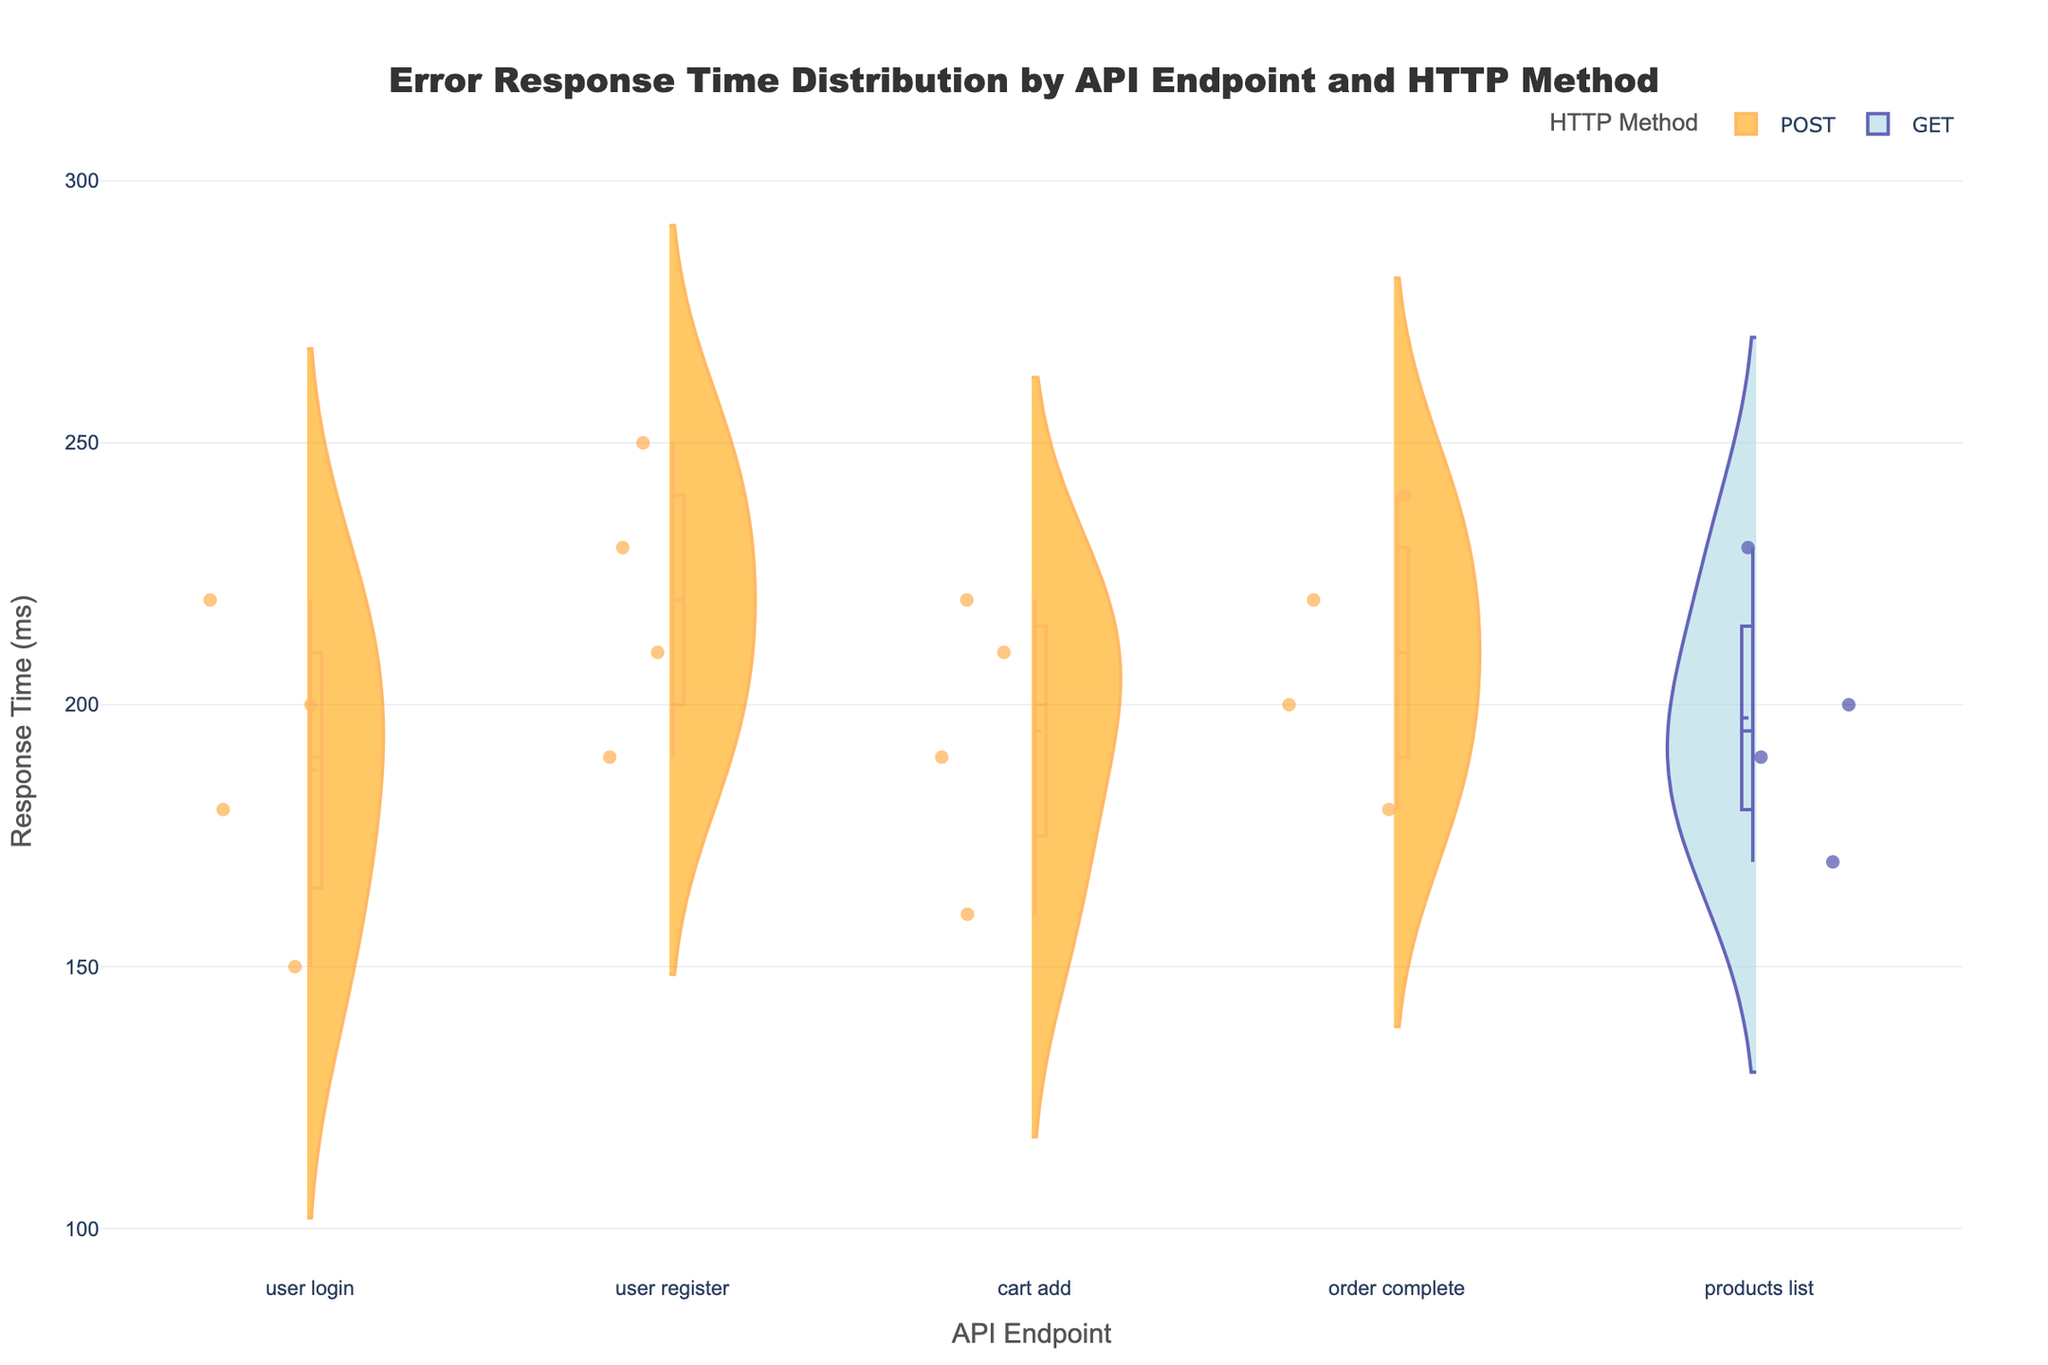What's the title of the chart? The title is prominently displayed at the top of the figure and is generally the first thing you notice.
Answer: Error Response Time Distribution by API Endpoint and HTTP Method What is on the x-axis? The x-axis usually labels the categories or groups being compared. In this case, it shows different API Endpoints represented with line breaks for clarity.
Answer: API Endpoint What is on the y-axis? The y-axis usually represents the variable being measured. In this chart, it is labeled as "Response Time (ms)" which measures the response times of various API endpoints.
Answer: Response Time (ms) Which HTTP method has overall higher response time variability? To determine variability, one needs to look at the spread of the violin plots. POST method has wider violin plots indicating higher variability in response times compared to the GET method.
Answer: POST How does the distribution of response times for `/user/login` endpoint compare between POST and GET methods? The POST method has a wider spread in response times as compared to GET. This is indicated by the larger, more extended violin plot for POST.
Answer: POST shows higher variability What is the average response time for POST requests on the `/order/complete` endpoint? The average response time can be estimated by looking at the mean line visible in the POST violin plot for `/order/complete`.
Answer: Around 210 ms For the `/products/list` endpoint, which HTTP Method has a lower median response time? The median can be inferred from the horizontal line in the middle of the violin plot. Here, the GET method has a slightly lower median response time compared to POST.
Answer: GET How many unique API endpoints are presented in the chart? By counting the different categories on the x-axis, we can determine the number of unique API endpoints shown. There are 5 unique API endpoints.
Answer: 5 Is there an API endpoint where GET requests have higher response times than POST? By visually comparing the top halves of the violin plots, none of the GET violin plots exceed the POST violin plots for the same endpoints.
Answer: No What is the shape and color difference between the violin plots for POST and GET methods? POST violin plots are positive-sided, filled with an orange color, while GET violin plots are negative-sided, filled with light blue. This helps distinguish between the two methods visually.
Answer: Orange for POST, Light Blue for GET 